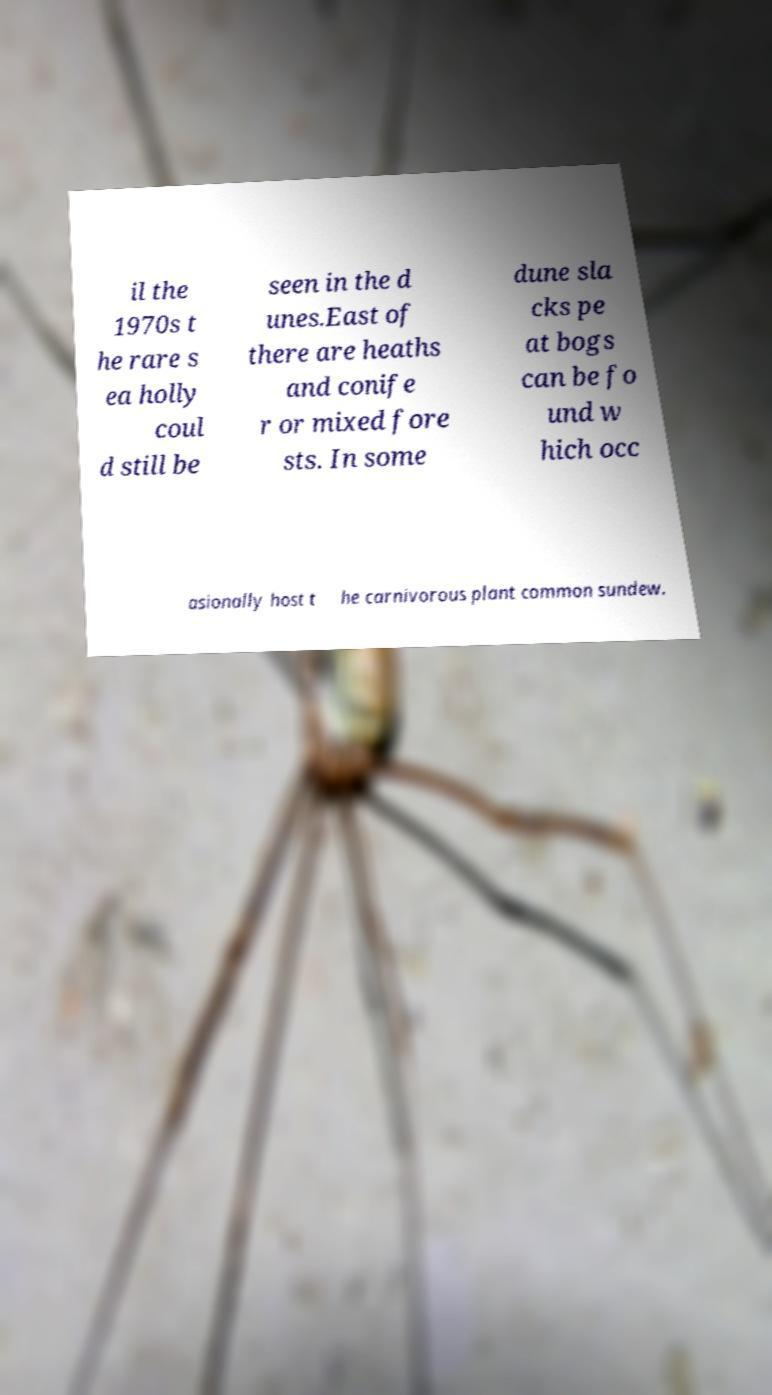What messages or text are displayed in this image? I need them in a readable, typed format. il the 1970s t he rare s ea holly coul d still be seen in the d unes.East of there are heaths and conife r or mixed fore sts. In some dune sla cks pe at bogs can be fo und w hich occ asionally host t he carnivorous plant common sundew. 